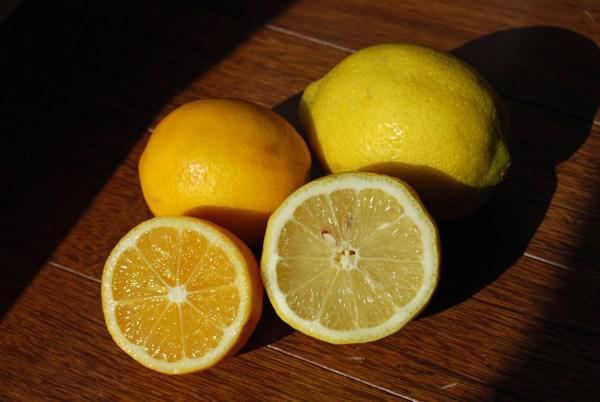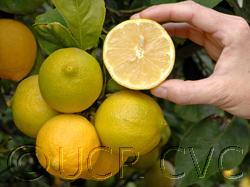The first image is the image on the left, the second image is the image on the right. For the images displayed, is the sentence "None of the lemons in the images have been sliced open." factually correct? Answer yes or no. No. The first image is the image on the left, the second image is the image on the right. Considering the images on both sides, is "All of the fruit is whole and is not on a tree." valid? Answer yes or no. No. 